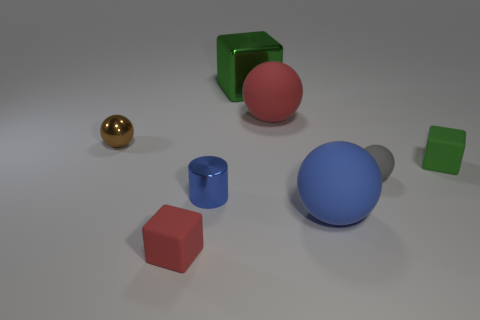Subtract all rubber balls. How many balls are left? 1 Subtract all cyan spheres. How many green blocks are left? 2 Subtract all red blocks. How many blocks are left? 2 Add 2 tiny gray matte balls. How many objects exist? 10 Subtract 2 balls. How many balls are left? 2 Subtract all cylinders. How many objects are left? 7 Subtract all blue spheres. Subtract all brown blocks. How many spheres are left? 3 Add 4 blue metal things. How many blue metal things exist? 5 Subtract 1 gray spheres. How many objects are left? 7 Subtract all small brown metallic things. Subtract all tiny brown objects. How many objects are left? 6 